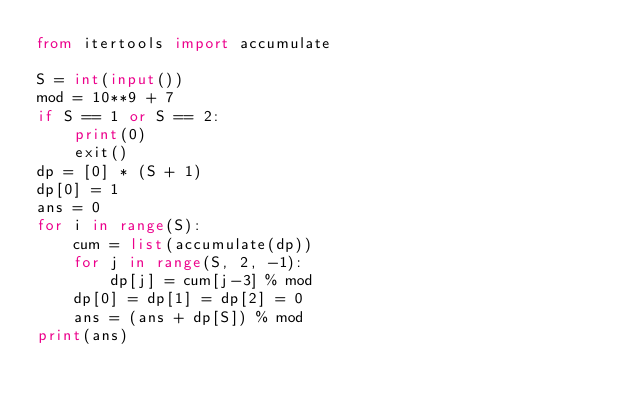<code> <loc_0><loc_0><loc_500><loc_500><_Python_>from itertools import accumulate

S = int(input())
mod = 10**9 + 7
if S == 1 or S == 2:
    print(0)
    exit()
dp = [0] * (S + 1)
dp[0] = 1
ans = 0
for i in range(S):
    cum = list(accumulate(dp))
    for j in range(S, 2, -1):
        dp[j] = cum[j-3] % mod
    dp[0] = dp[1] = dp[2] = 0
    ans = (ans + dp[S]) % mod
print(ans)</code> 